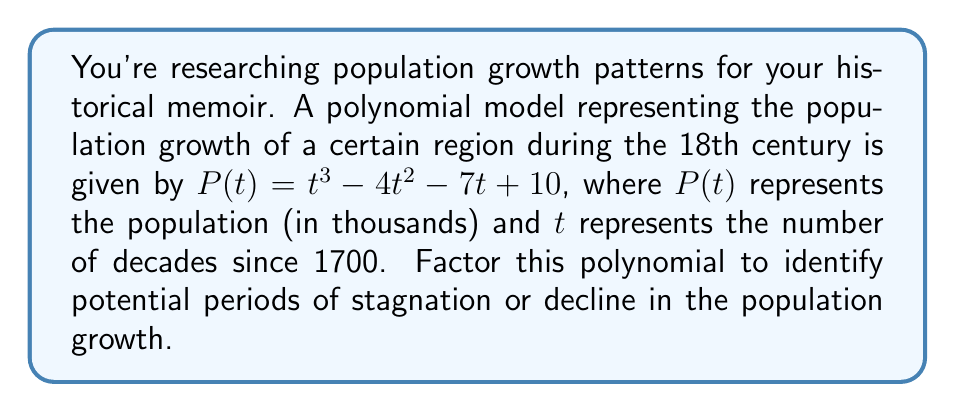Help me with this question. To factor this polynomial, we'll follow these steps:

1) First, let's check if there are any rational roots using the rational root theorem. The possible rational roots are the factors of the constant term: $\pm 1, \pm 2, \pm 5, \pm 10$.

2) Testing these values, we find that $P(1) = 0$. So $(t-1)$ is a factor.

3) We can use polynomial long division to divide $P(t)$ by $(t-1)$:

   $$\frac{t^3 - 4t^2 - 7t + 10}{t - 1} = t^2 - 3t - 10$$

4) Now we need to factor the quadratic $t^2 - 3t - 10$. We can do this by finding two numbers that multiply to give $-10$ and add to give $-3$. These numbers are $-5$ and $2$.

5) Therefore, $t^2 - 3t - 10 = (t-5)(t+2)$

6) Combining all factors, we get:

   $$P(t) = (t-1)(t-5)(t+2)$$

This factorization reveals that the population growth model has three roots: $t=1$, $t=5$, and $t=-2$. In the context of the problem, $t=1$ and $t=5$ represent potential periods of stagnation in population growth, occurring in 1710 and 1750 respectively. The $t=-2$ root is not meaningful in this historical context as it would represent a time before 1700.
Answer: $$P(t) = (t-1)(t-5)(t+2)$$ 